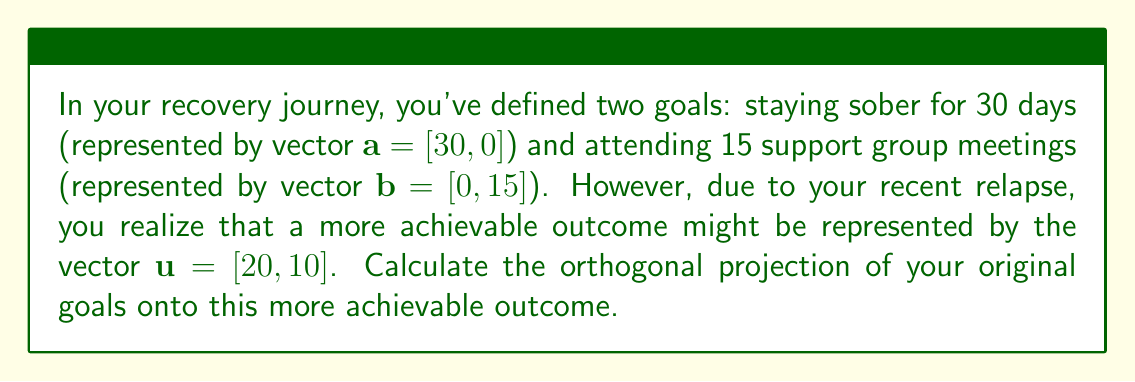Help me with this question. To calculate the orthogonal projection of the goals onto the achievable outcome, we'll follow these steps:

1) First, we need to combine the two goal vectors into a single vector:
   $\mathbf{v} = \mathbf{a} + \mathbf{b} = [30, 0] + [0, 15] = [30, 15]$

2) The formula for the orthogonal projection of $\mathbf{v}$ onto $\mathbf{u}$ is:
   $\text{proj}_\mathbf{u} \mathbf{v} = \frac{\mathbf{v} \cdot \mathbf{u}}{\|\mathbf{u}\|^2} \mathbf{u}$

3) Let's calculate each part:
   $\mathbf{v} \cdot \mathbf{u} = 30 \cdot 20 + 15 \cdot 10 = 600 + 150 = 750$
   
   $\|\mathbf{u}\|^2 = 20^2 + 10^2 = 400 + 100 = 500$

4) Now we can substitute these values into our projection formula:
   $\text{proj}_\mathbf{u} \mathbf{v} = \frac{750}{500} \mathbf{u} = 1.5 \mathbf{u} = 1.5 [20, 10] = [30, 15]$

5) This result shows that your original goals are actually achievable within the framework of your new, more realistic outcome. The projection equals your original goal vector, meaning no adjustment is necessary.
Answer: $[30, 15]$ 